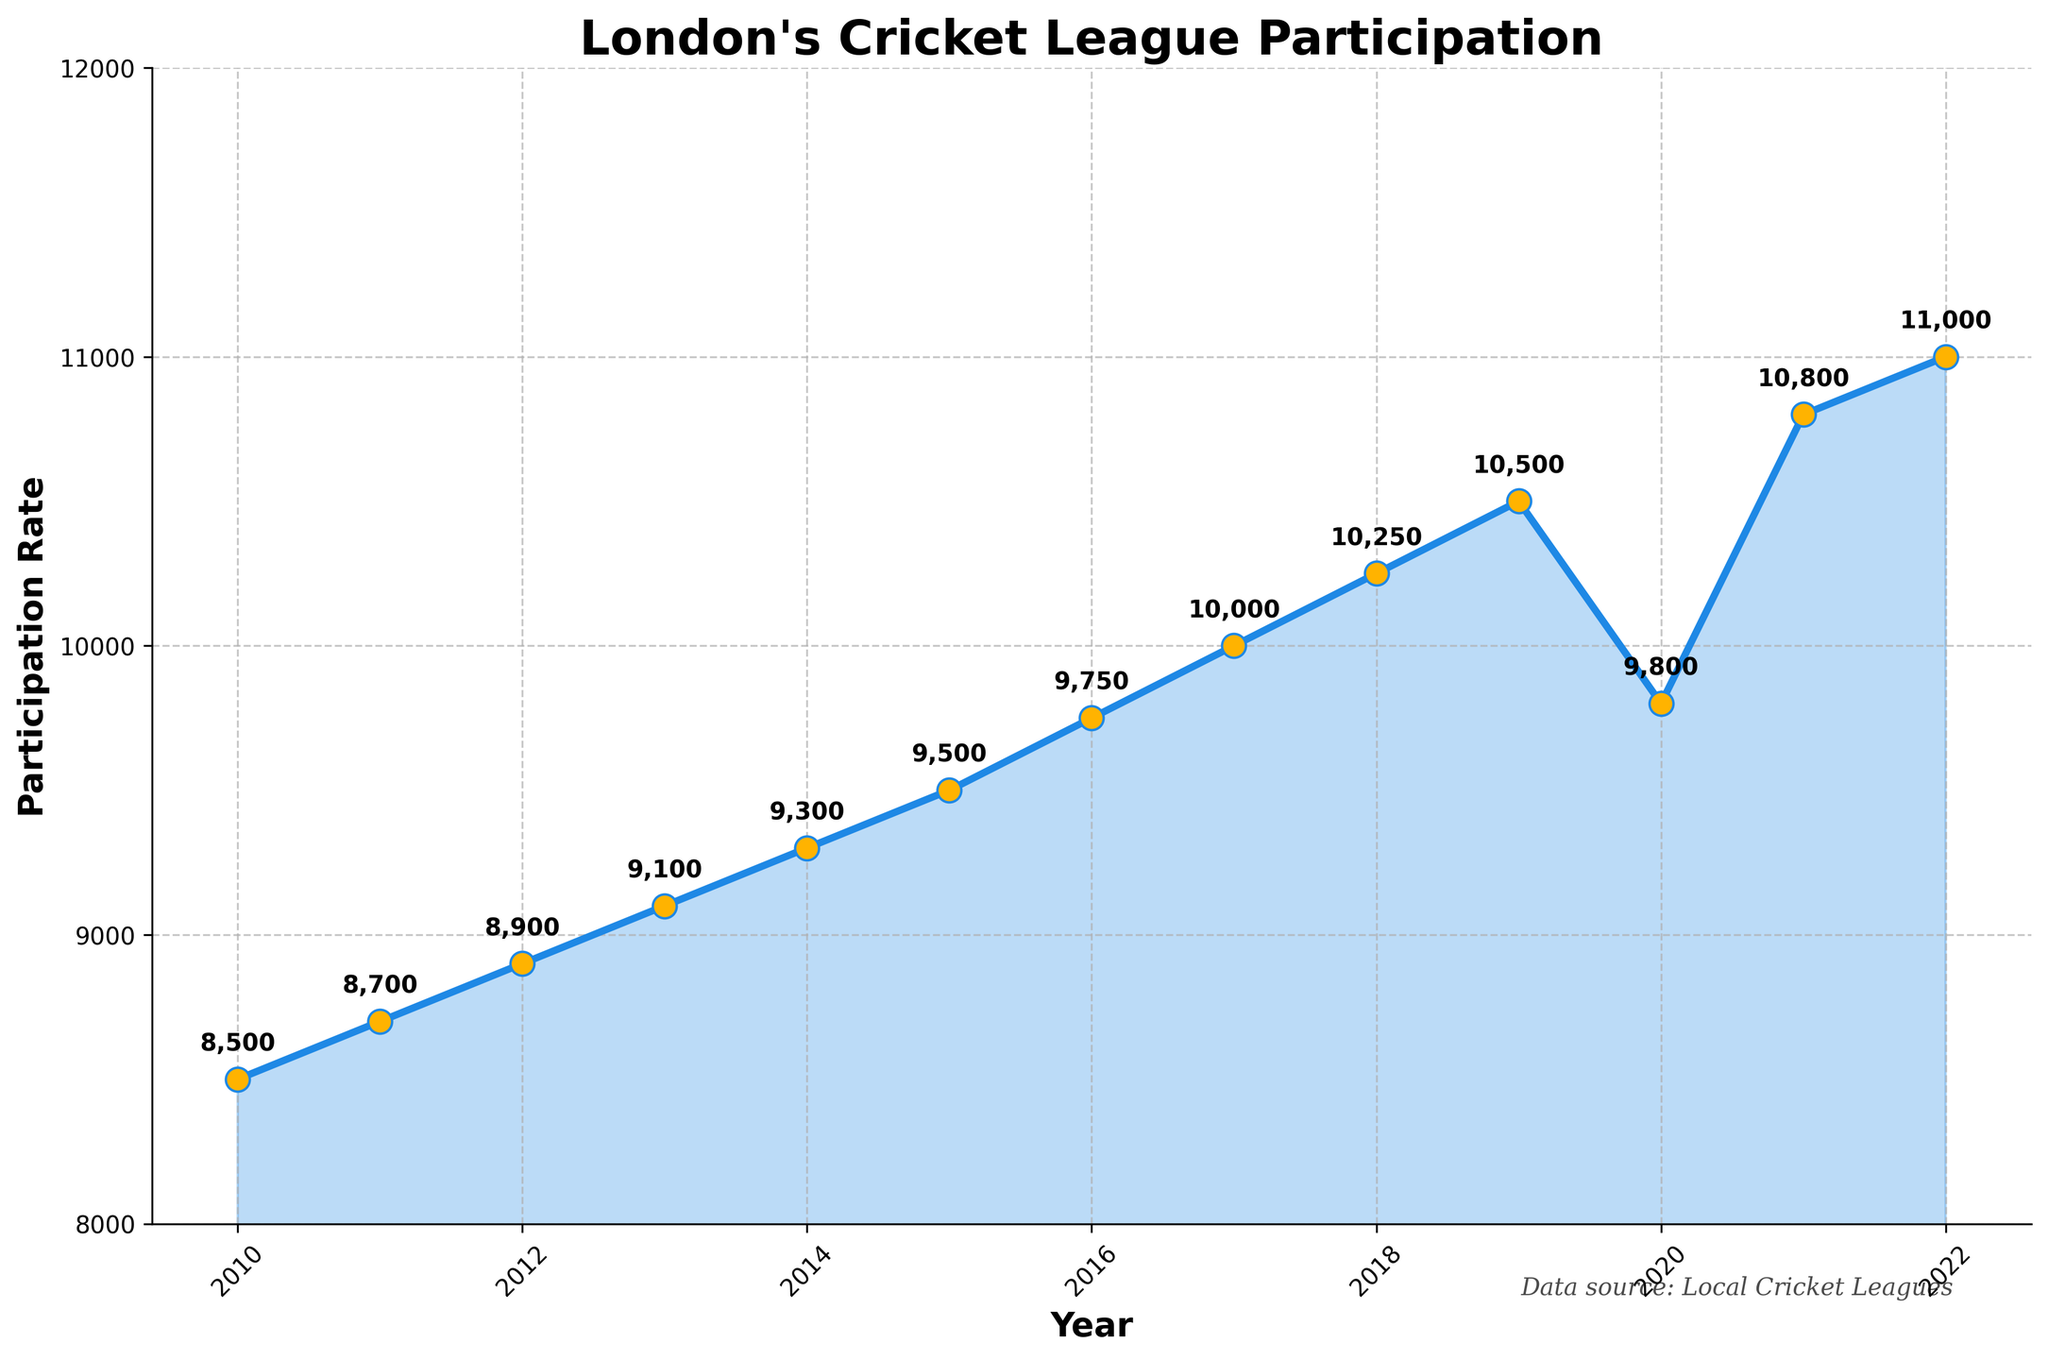What is the title of the figure? The title of the figure is displayed prominently at the top of the plot.
Answer: London's Cricket League Participation How many data points are shown in the figure? Each yearly participation rate is plotted as a point, starting from 2010 to 2022.
Answer: 13 What is the participation rate for the year 2017? Locate the year 2017 along the x-axis and track upwards to the corresponding participation rate.
Answer: 10,000 Is there any annotation on the plot? The figure annotates each data point with the specific participation rate value.
Answer: Yes What happened to the participation rate in 2020? Identify the year 2020 on the x-axis and note the corresponding participation rate value, which shows a decrease.
Answer: It decreased to 9800 What is the highest participation rate recorded, and in which year did it occur? Examine the y-axis values and identify the peak participation rate along with the corresponding year.
Answer: 11,000 in 2022 What is the difference in participation rate between 2015 and 2016? Subtract the participation rate of 2015 from that of 2016 (9750 - 9500).
Answer: 250 During which year(s) did the participation rate see the largest increase compared to the previous year? Calculate the annual increments and identify the year with the largest increase (e.g., 2021 increased by 1000 compared to 2020).
Answer: 2021 How did the participation rate change from 2019 to 2020 and then to 2021? Note the values for 2019, 2020, and 2021, and track the increase or decrease across these years (2019 to 2020 saw a decrease; 2020 to 2021 saw an increase).
Answer: Decreased from 10,500 to 9800, then increased to 10,800 On average, how much did the participation rate increase per year from 2010 to 2019? Calculate the average annual increase by summing all annual increases and dividing by the number of years ([(8700 - 8500) + (8900 - 8700) + ... + (10500 - 10250)] / 9).
Answer: Approximately 500 per year 